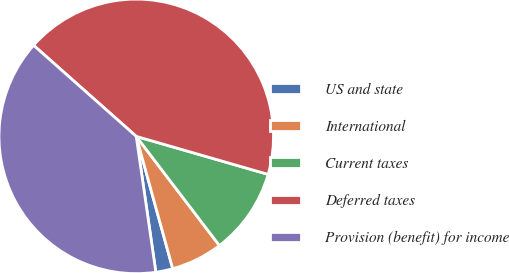Convert chart. <chart><loc_0><loc_0><loc_500><loc_500><pie_chart><fcel>US and state<fcel>International<fcel>Current taxes<fcel>Deferred taxes<fcel>Provision (benefit) for income<nl><fcel>2.0%<fcel>6.08%<fcel>10.17%<fcel>42.92%<fcel>38.83%<nl></chart> 